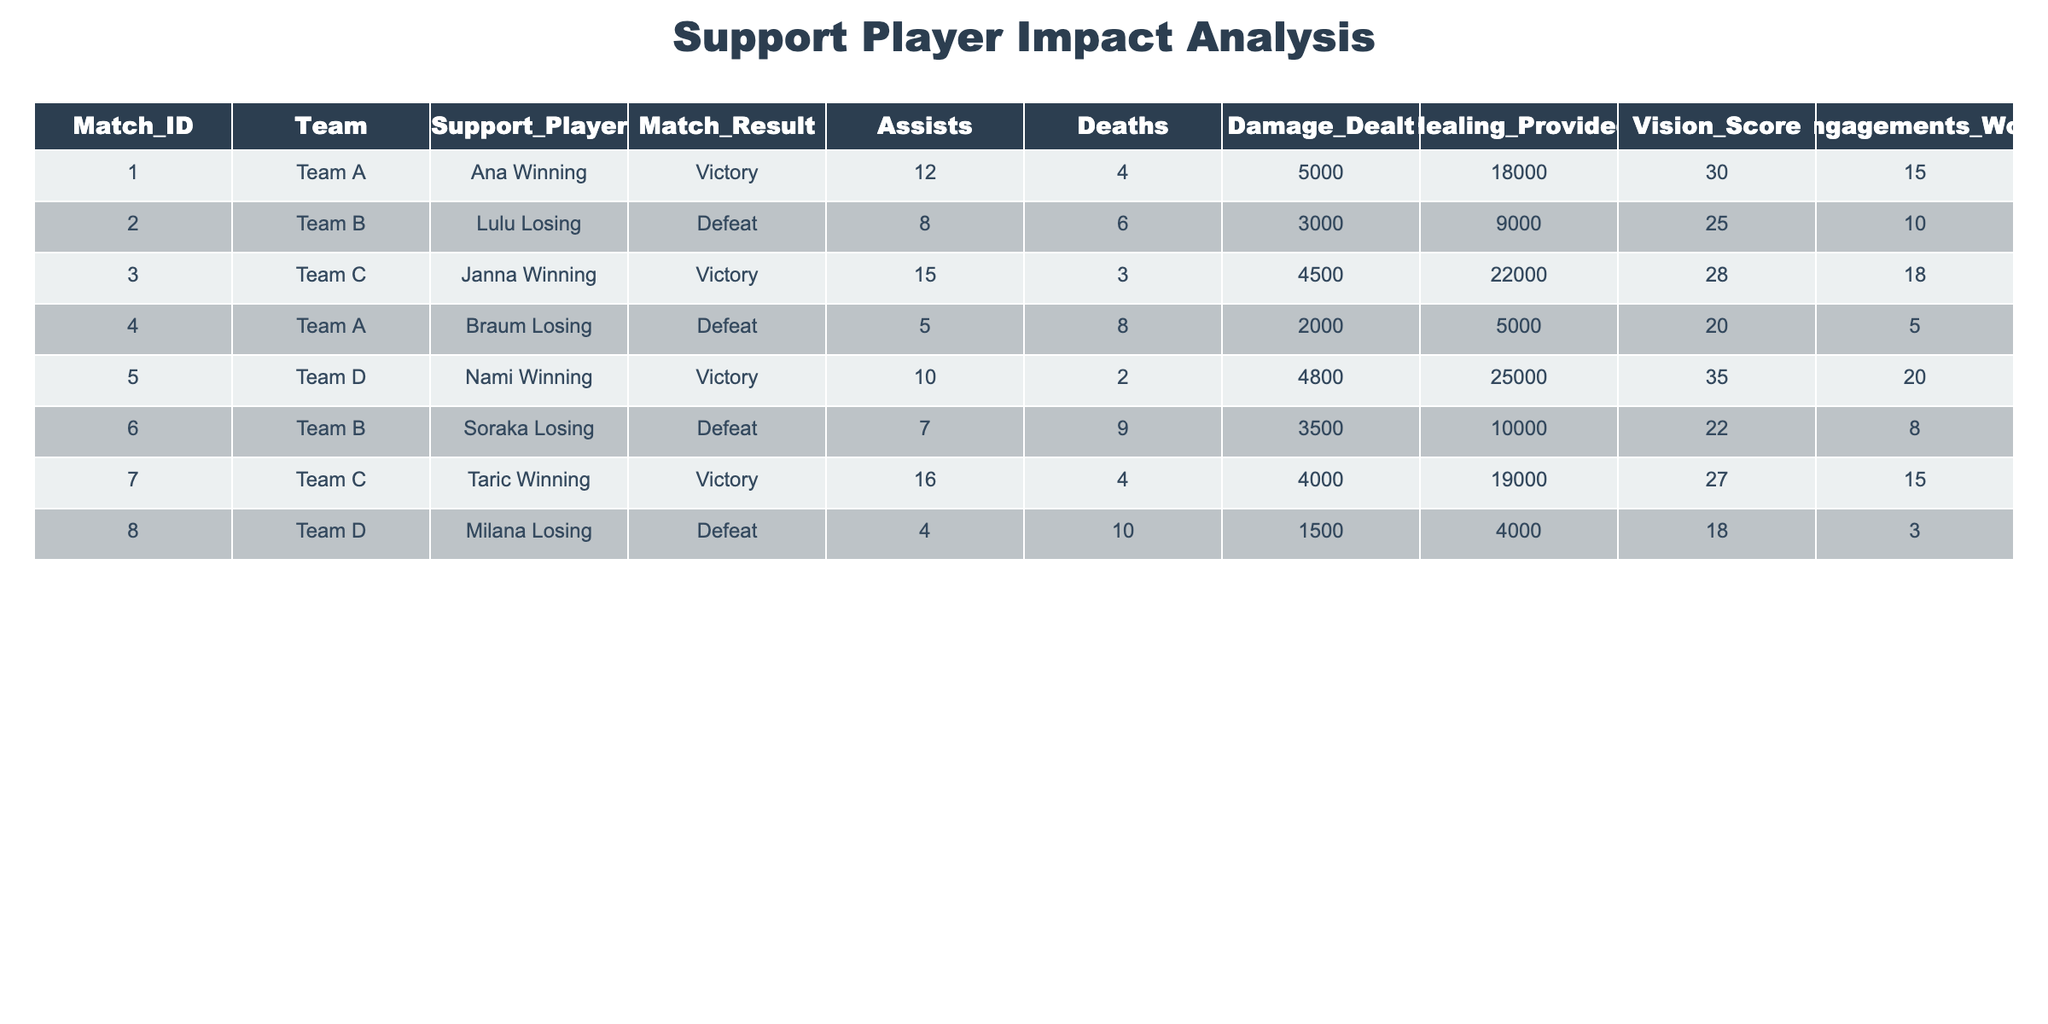What is the total number of assists made by winning support players? From the table, we identify the winning support players: Ana (12 assists), Janna (15 assists), Nami (10 assists), and Taric (16 assists). We then sum their assists: 12 + 15 + 10 + 16 = 53.
Answer: 53 How many engagement wins did the losing support players achieve? The losing support players are Lulu (10 engagements), Braum (5 engagements), Soraka (8 engagements), and Milana (3 engagements). We sum their engagement wins: 10 + 5 + 8 + 3 = 26.
Answer: 26 Did any support player achieve more assists than deaths in their match? Analyzing each support player's assists and deaths: Ana (12 assists, 4 deaths), Janna (15 assists, 3 deaths), Nami (10 assists, 2 deaths), Taric (16 assists, 4 deaths), Lulu (8 assists, 6 deaths), Braum (5 assists, 8 deaths), Soraka (7 assists, 9 deaths), Milana (4 assists, 10 deaths). Players achieving more assists than deaths are Ana, Janna, Nami, and Taric, so the answer is yes.
Answer: Yes What is the average healing provided by support players in matches won? The healing provided by winning support players is: Ana (18000), Janna (22000), Nami (25000), Taric (19000). To find the average, we sum these values: 18000 + 22000 + 25000 + 19000 = 84000, and divide by the number of matches (4): 84000 / 4 = 21000.
Answer: 21000 Which team had the highest vision score and what was it? We check the vision scores for each match: Team A (30), Team B (25), Team C (28), Team A (20), Team D (35), Team B (22), Team C (27), Team D (18). The highest vision score is 35 by Team D (Nami).
Answer: 35 